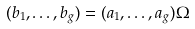Convert formula to latex. <formula><loc_0><loc_0><loc_500><loc_500>( b _ { 1 } , \dots , b _ { g } ) = ( a _ { 1 } , \dots , a _ { g } ) \Omega</formula> 